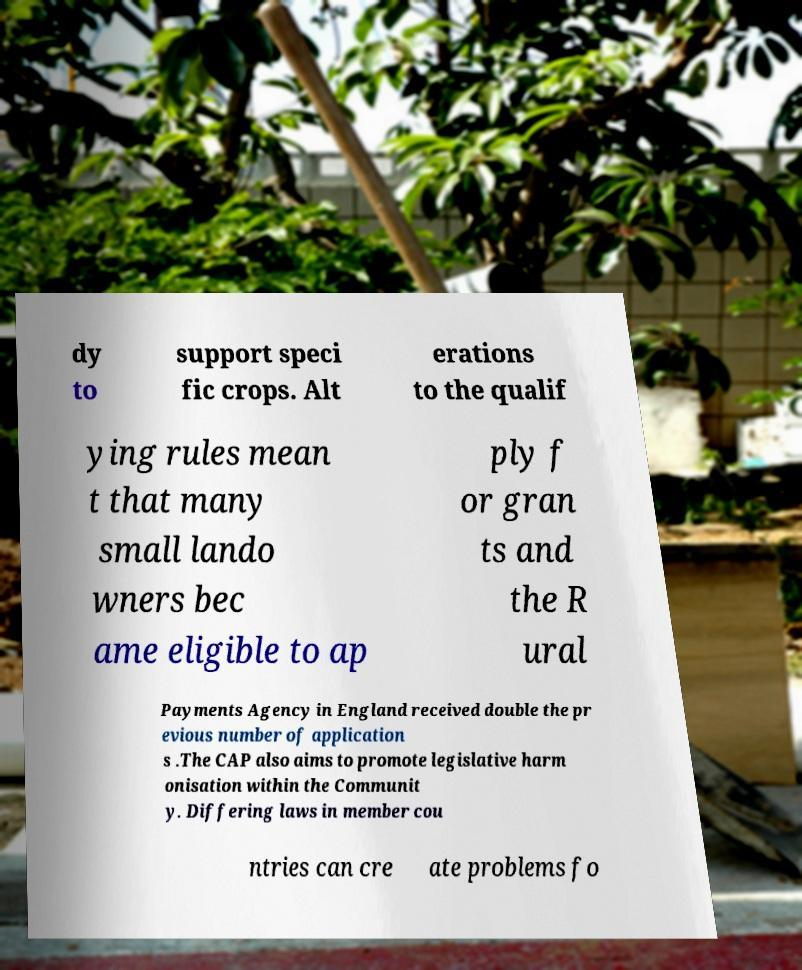Can you read and provide the text displayed in the image?This photo seems to have some interesting text. Can you extract and type it out for me? dy to support speci fic crops. Alt erations to the qualif ying rules mean t that many small lando wners bec ame eligible to ap ply f or gran ts and the R ural Payments Agency in England received double the pr evious number of application s .The CAP also aims to promote legislative harm onisation within the Communit y. Differing laws in member cou ntries can cre ate problems fo 